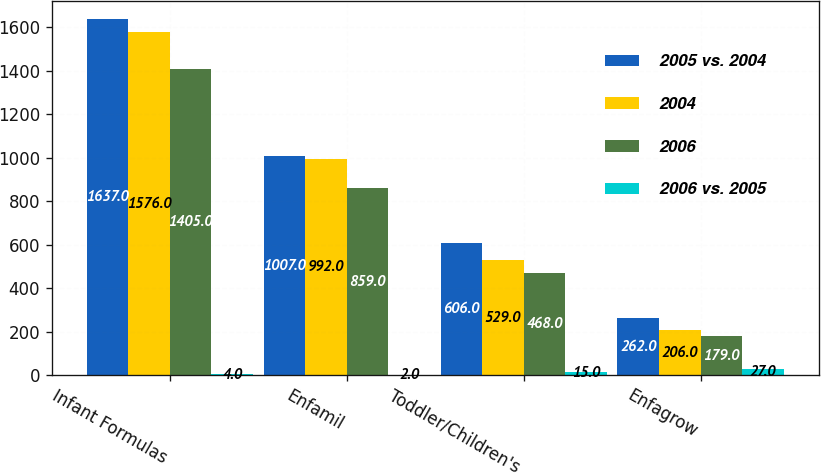Convert chart. <chart><loc_0><loc_0><loc_500><loc_500><stacked_bar_chart><ecel><fcel>Infant Formulas<fcel>Enfamil<fcel>Toddler/Children's<fcel>Enfagrow<nl><fcel>2005 vs. 2004<fcel>1637<fcel>1007<fcel>606<fcel>262<nl><fcel>2004<fcel>1576<fcel>992<fcel>529<fcel>206<nl><fcel>2006<fcel>1405<fcel>859<fcel>468<fcel>179<nl><fcel>2006 vs. 2005<fcel>4<fcel>2<fcel>15<fcel>27<nl></chart> 